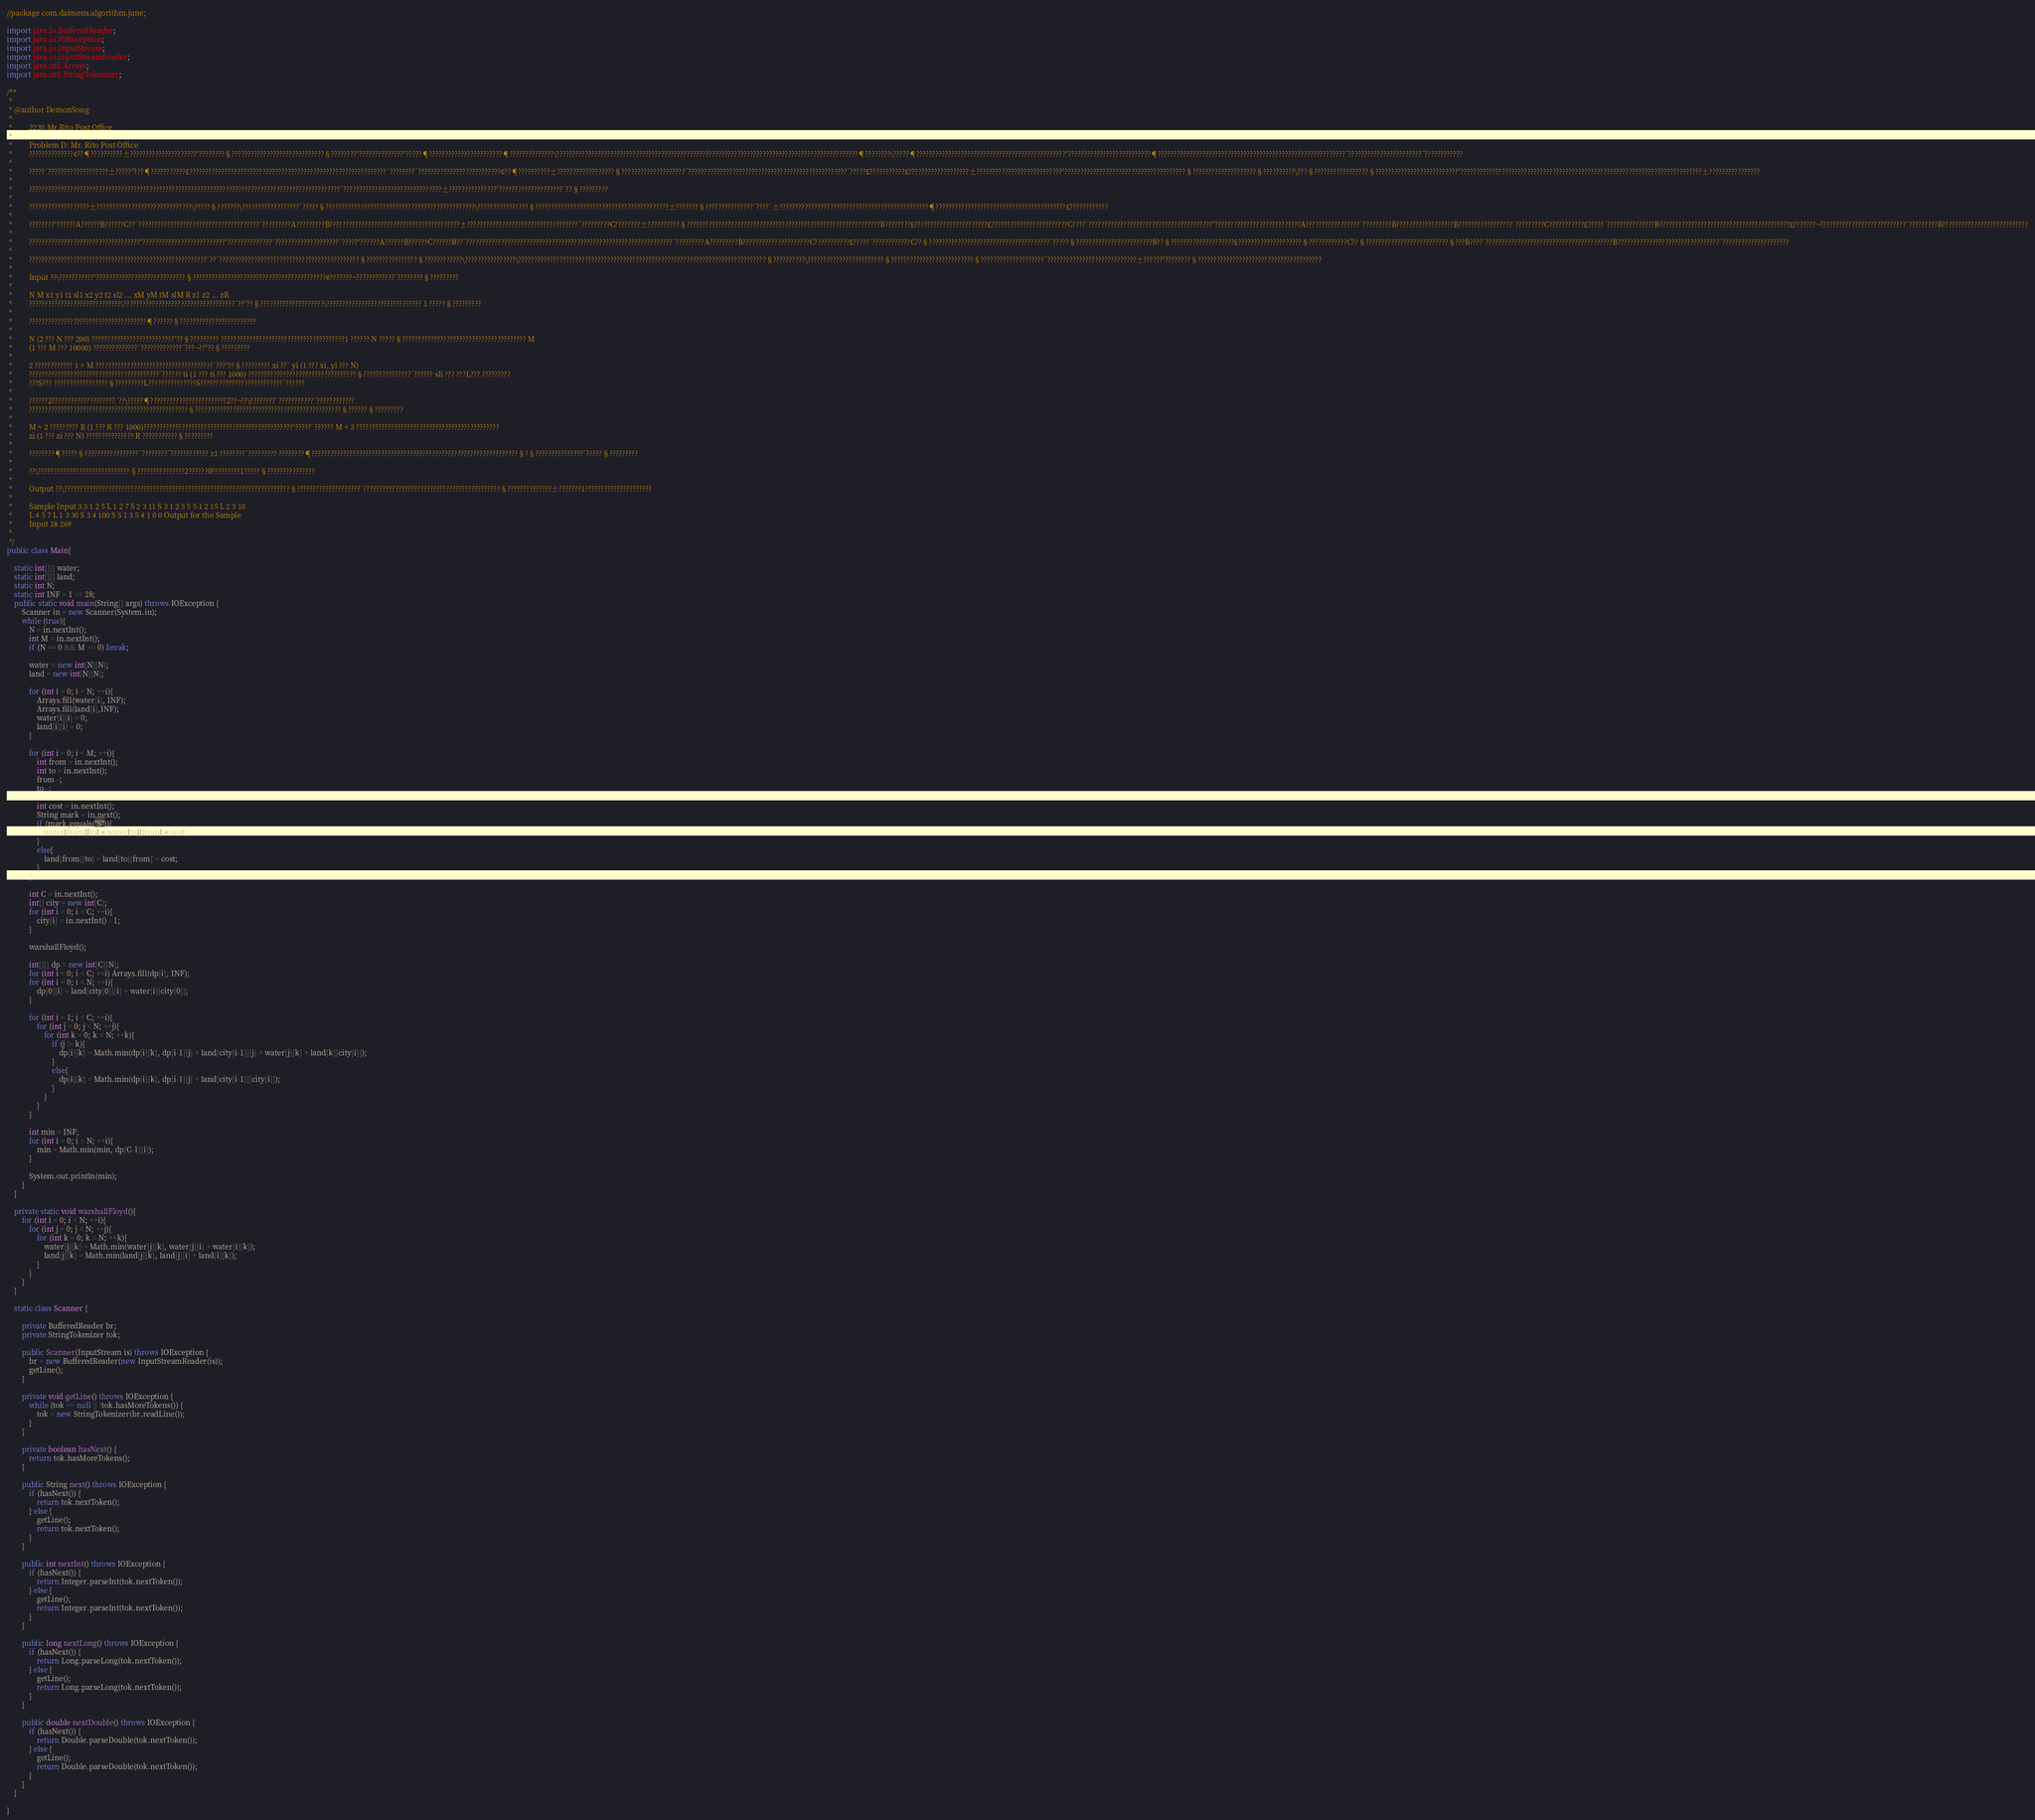<code> <loc_0><loc_0><loc_500><loc_500><_Java_>//package com.daimens.algorithm.june;

import java.io.BufferedReader;
import java.io.IOException;
import java.io.InputStream;
import java.io.InputStreamReader;
import java.util.Arrays;
import java.util.StringTokenizer;

/**
 * 
 * @author DemonSong
 * 
 *         2220.Mr.Rito Post Office
 * 
 *         Problem D: Mr. Rito Post Office
 *         ??????????????¢??¶??????????±?????????????????????°????????§?????????????????????????????§????????°??????????????°?????¶???????????????????????¶??????????????\???????????????????????????????????????????????????????????????????????????????????????????????¶????????\?????¶???????????????????????????????????????????????°??????????????????????????¶???????????????????????????????????????????????????????????¨???????????????????????¨????????????
 * 
 *         ?????´???????????????????±?????°???¶???????????£??????????????????????????????????????????????????????????????´????????¨??????????????????????????¢??¶??????????±??????????????????§????????????????????¨??????????????????????????????????????????????????¨?????£???????????£???????????????????±???????????????????????????°??????????????????????????????????????§????????????????????§??????????\???§?????????????????§??????????????????????????°????????????????????????????????????????????????????????????????????????????±????????????????
 * 
 *         ??????????????????????????????????????????????????????????????????????????????????????????????????¨???????????????????????????????±???????????????°????????????????????¨??§?????????
 * 
 *         ???????????????????±??????????????????????????????\?????§???????\??????????????????¨?????§???????????????????????????????????????????????\????????????????§??????????????????????????????????????????±???????§???????????????¨????¨±???????????????????????????????????????????????¶?????????????????????????????????????????£????????????
 * 
 *         ????????°??????A??????B??????C??¨??????????????????????????????????????´?????????A?????????B?????????????????????????????????????????±???????????????????????????????????¨?????????C????????±??????????§?????????????????????????????????????????????????????????????B????????£???????????????????????£????????????????????????C????¨???????????????????????????????????????°???????????????????????????A?????????????????¨?????????B??????????????????B?????????????????¨?????????C???????????£?????´???????????????B?????????????????????????????????????????£???????¬???????????????????????????´?????????B???????????????????????????
 * 
 *         ???????????????????????????????????°??????????????????????????°??????????????´????????????????????¨?????°??????A??????B??????C??????B??¨?????????????????????????????????????????????????????????????????¨?????????A?????????B?????????????????????C???????????£?????´????????????C??§??????????????????????????????????????¨?????§????????????????????????B??§????????????????????£????????????????????§????????????C??§??????????????????????????§???B????¨????????????????????????????????????????B????????????????????????????????¨?????????????????????
 * 
 *         ????????????????????????????????????????????????????????¨??¨????????????????????????????????????????????§????????????????§????????????\????????????????\??????????????????????????????????????????????????????????????????????????????§??????????\????????????????????????§??????????????????????????§????????????????????¨????????????????????????????±??????°????????§???????????????????????????????????????
 * 
 *         Input ??\???????????°????????????????????????????§??????????????????????????????????????????¢???????¬????????????¨????????§?????????
 * 
 *         N M x1 y1 t1 sl1 x2 y2 t2 sl2 ... xM yM tM slM R z1 z2 ... zR
 *         ?????????????????????????????\???????????????????????????????????´??°??§????????????????????\?????????????????????????????? 1 ?????§?????????
 * 
 *         ?????????????????????????????????????¶??????§????????????????????????
 * 
 *         N (2 ??? N ??? 200) ??????????????????????????°??§????????? ???????????????????????????????????????1 ?????? N ?????§??????????????????????????????????????? M
 *         (1 ??? M ??? 10000) ??????????????¨?????????????¨???¬??°??§?????????
 * 
 *         2 ???????????? 1 + M ?????????????????????????????????????¨???°??§????????? xi ??¨ yi (1 ??? xi, yi ??? N)
 *         ?????????????????????????????????????????¨?????? ti (1 ??? ti ??? 1000) ??????????????????????????????????§???????????????¨?????? sli ??? ???L??? ?????????
 *         ???S??? ?????????????????§?????????L???????????????S??????????????????????????¨??????
 * 
 *         ??????2????????????????????´??\?????¶????????????????????????2??¬??\????????¨???????????¨????????????
 *         ??????????????????????????????????????????????????§??????????????????????????????????????????????§??????§?????????
 * 
 *         M + 2 ????????? R (1 ??? R ??? 1000)???????????????????????????????????????????????°?????¨?????? M + 3 ?????????????????????????????????????????????
 *         zi (1 ??? zi ??? N) ??????????????? R ???????????§?????????
 * 
 *         ????????¶?????§?????????????????¨????????¨???????????? z1 ????????¨????????? ????????¶?????????????????????????????????????????????????????????????????§?§???????????????¨?????§?????????
 * 
 *         ??\?????????????????????????????§???????????????2??????0?????????1?????§???????????????
 * 
 *         Output ??\???????????????????????????????????????????????????????????????????????§????????????????????¨???????????????????????????????????????????§??????????????±???????1?????????????????????
 * 
 *         Sample Input 3 3 1 2 5 L 1 2 7 S 2 3 11 S 3 1 2 3 5 5 1 2 15 L 2 3 10
 *         L 4 5 7 L 1 3 30 S 3 4 100 S 5 1 3 5 4 1 0 0 Output for the Sample
 *         Input 18 269
 *
 */
public class Main{
	
	static int[][] water;
	static int[][] land;
	static int N;
	static int INF = 1 << 28;
	public static void main(String[] args) throws IOException {
		Scanner in = new Scanner(System.in);
		while (true){
			N = in.nextInt();
			int M = in.nextInt();
			if (N == 0 && M == 0) break;
			
			water = new int[N][N];
			land = new int[N][N];
			
			for (int i = 0; i < N; ++i){
				Arrays.fill(water[i], INF);
				Arrays.fill(land[i],INF);
				water[i][i] = 0;
				land[i][i] = 0;
			}
			
			for (int i = 0; i < M; ++i){
				int from = in.nextInt();
				int to = in.nextInt();
				from--;
				to--;
				
				int cost = in.nextInt();
				String mark = in.next();
				if (mark.equals("S")){
					water[from][to] = water[to][from] = cost;
				}
				else{
					land[from][to] = land[to][from] = cost;
				}
			}
			
			int C = in.nextInt();
			int[] city = new int[C];
			for (int i = 0; i < C; ++i){
				city[i] = in.nextInt() - 1;
			}
			
			warshallFloyd();
			
			int[][] dp = new int[C][N];
			for (int i = 0; i < C; ++i) Arrays.fill(dp[i], INF);
			for (int i = 0; i < N; ++i){
				dp[0][i] = land[city[0]][i] + water[i][city[0]];
			}
			
			for (int i = 1; i < C; ++i){
				for (int j = 0; j < N; ++j){
					for (int k = 0; k < N; ++k){
						if (j != k){
							dp[i][k] = Math.min(dp[i][k], dp[i-1][j] + land[city[i-1]][j] + water[j][k] + land[k][city[i]]);
						}
						else{
							dp[i][k] = Math.min(dp[i][k], dp[i-1][j] + land[city[i-1]][city[i]]);
						}
					}
				}
			}
			
			int min = INF;
			for (int i = 0; i < N; ++i){
				min = Math.min(min, dp[C-1][i]);
			}
			
			System.out.println(min);
		}
	}
	
	private static void warshallFloyd(){ 
		for (int i = 0; i < N; ++i){
			for (int j = 0; j < N; ++j){
				for (int k = 0; k < N; ++k){
					water[j][k] = Math.min(water[j][k], water[j][i] + water[i][k]);
					land[j][k] = Math.min(land[j][k], land[j][i] + land[i][k]);
				}
			}
		}
	}
	
	static class Scanner {

		private BufferedReader br;
		private StringTokenizer tok;

		public Scanner(InputStream is) throws IOException {
			br = new BufferedReader(new InputStreamReader(is));
			getLine();
		}

		private void getLine() throws IOException {
			while (tok == null || !tok.hasMoreTokens()) {
				tok = new StringTokenizer(br.readLine());
			}
		}

		private boolean hasNext() {
			return tok.hasMoreTokens();
		}

		public String next() throws IOException {
			if (hasNext()) {
				return tok.nextToken();
			} else {
				getLine();
				return tok.nextToken();
			}
		}

		public int nextInt() throws IOException {
			if (hasNext()) {
				return Integer.parseInt(tok.nextToken());
			} else {
				getLine();
				return Integer.parseInt(tok.nextToken());
			}
		}

		public long nextLong() throws IOException {
			if (hasNext()) {
				return Long.parseLong(tok.nextToken());
			} else {
				getLine();
				return Long.parseLong(tok.nextToken());
			}
		}

		public double nextDouble() throws IOException {
			if (hasNext()) {
				return Double.parseDouble(tok.nextToken());
			} else {
				getLine();
				return Double.parseDouble(tok.nextToken());
			}
		}
	}

}</code> 